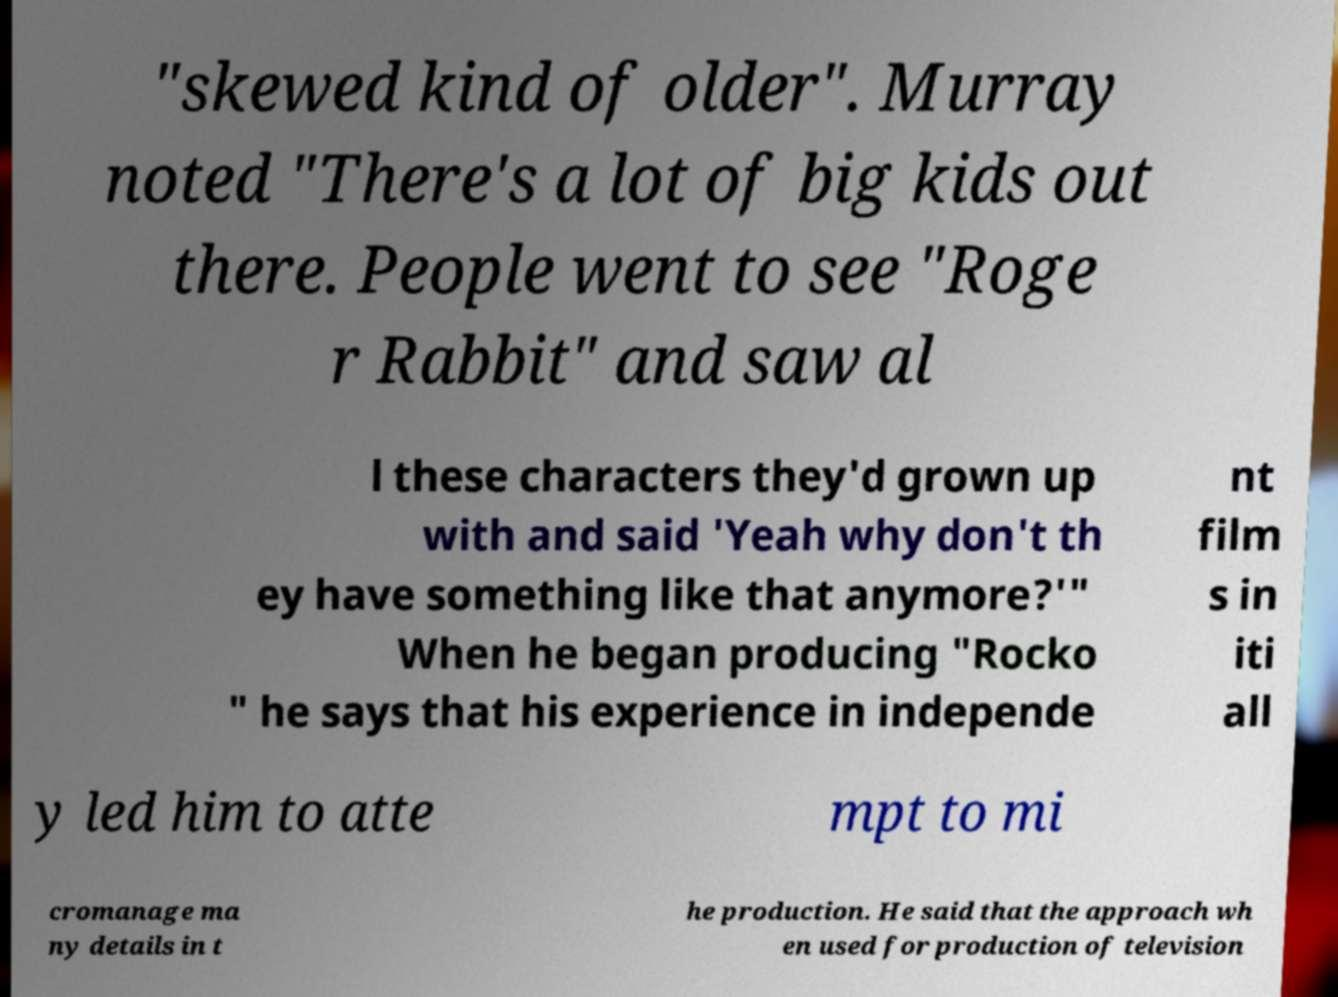What messages or text are displayed in this image? I need them in a readable, typed format. "skewed kind of older". Murray noted "There's a lot of big kids out there. People went to see "Roge r Rabbit" and saw al l these characters they'd grown up with and said 'Yeah why don't th ey have something like that anymore?'" When he began producing "Rocko " he says that his experience in independe nt film s in iti all y led him to atte mpt to mi cromanage ma ny details in t he production. He said that the approach wh en used for production of television 